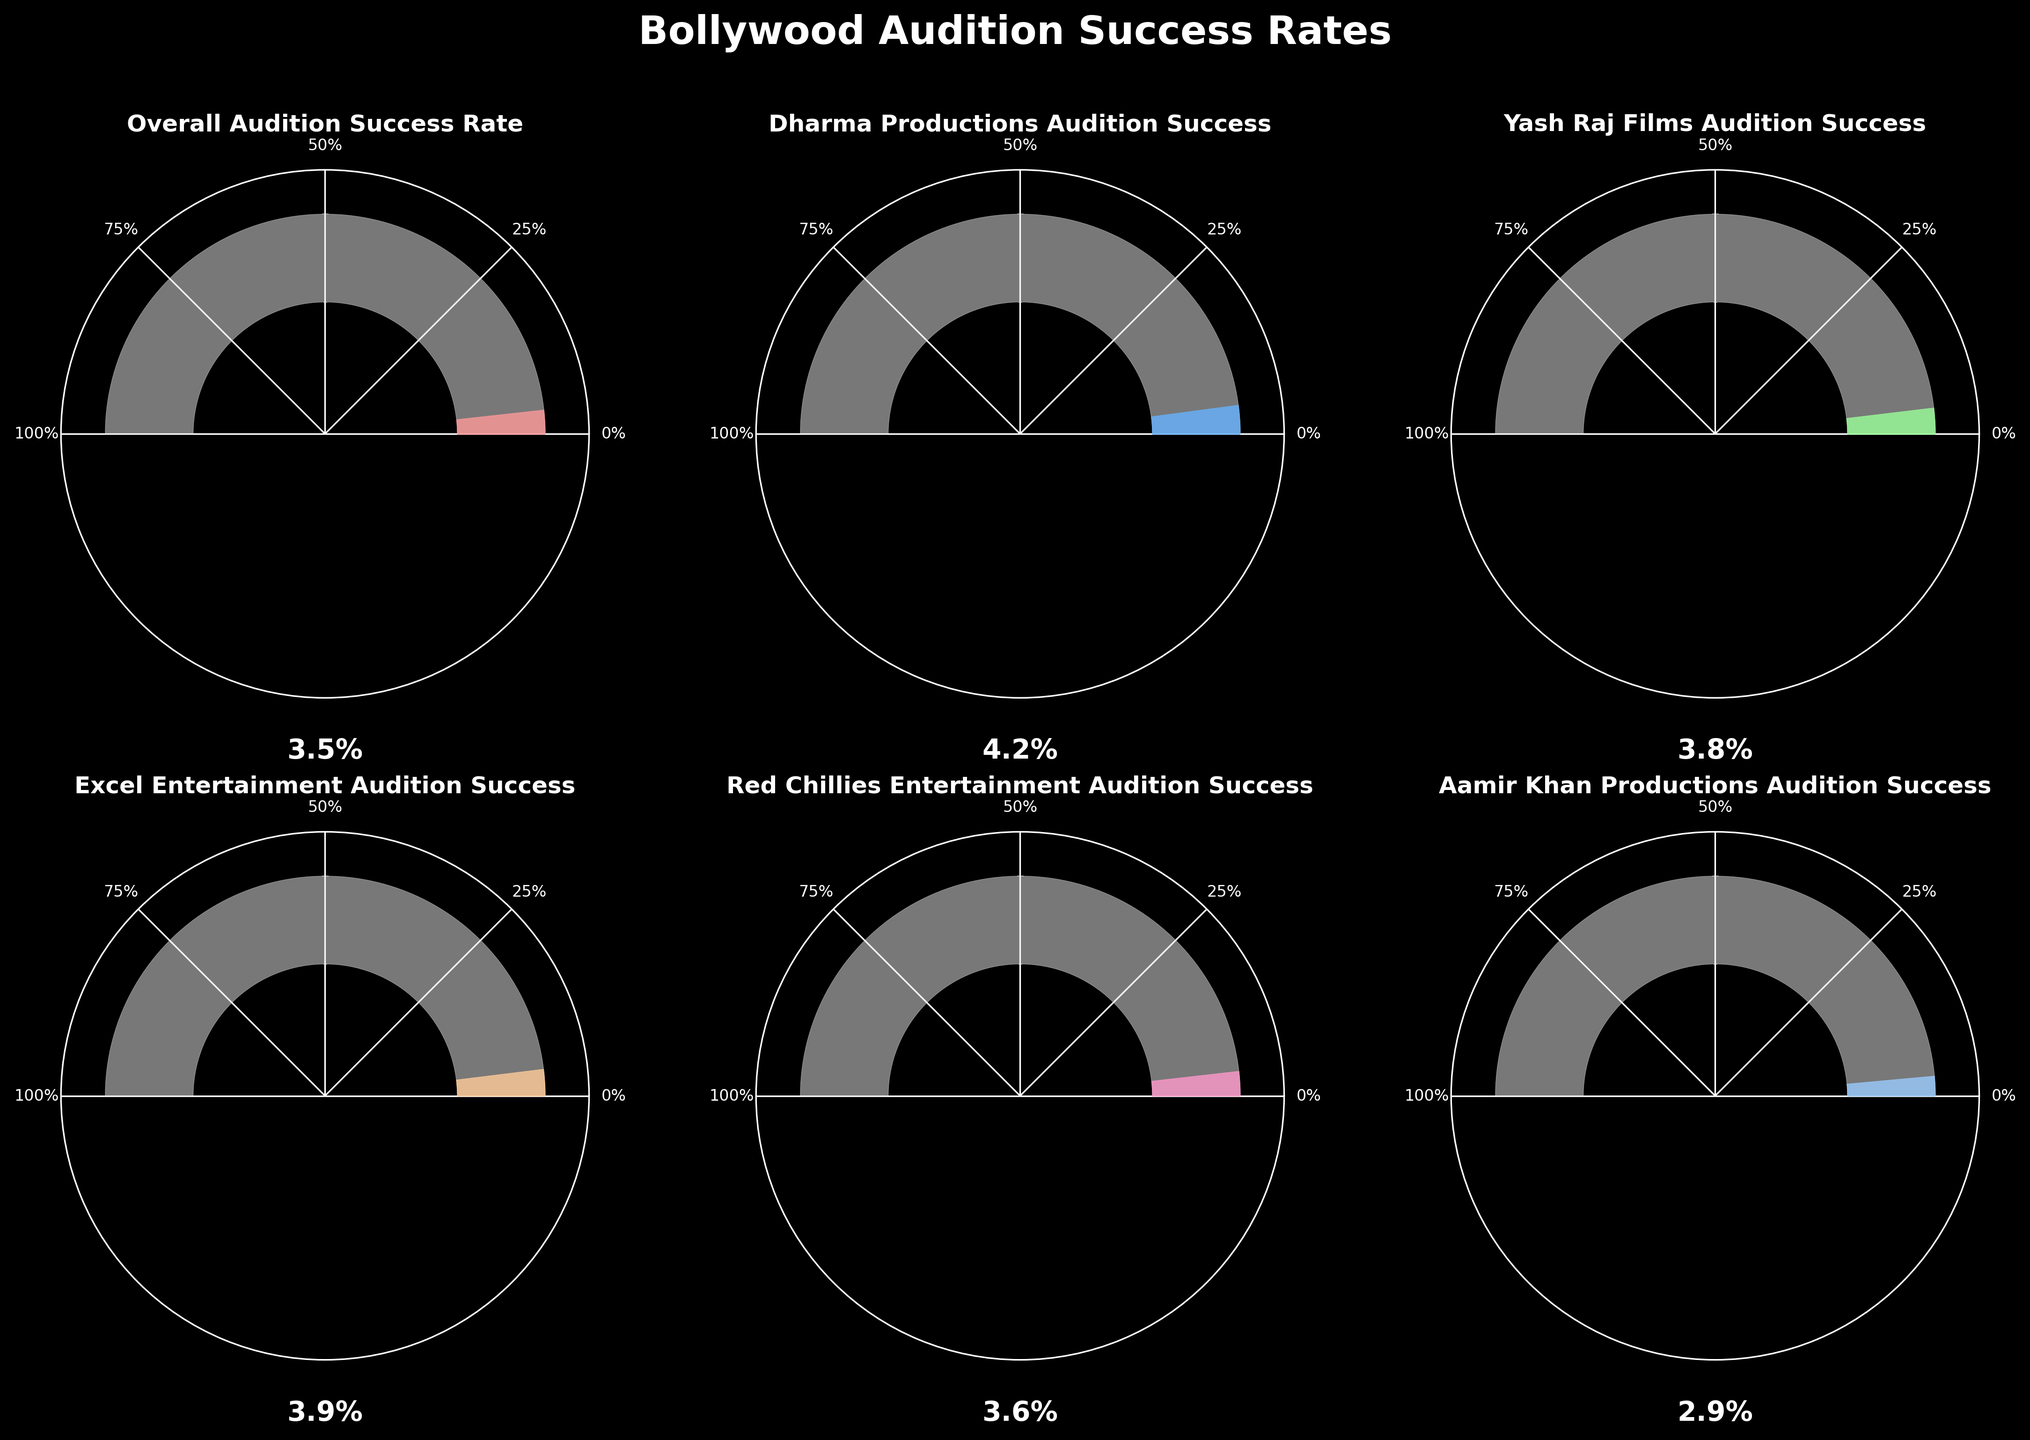What's the overall audition success rate for upcoming Bollywood productions? The title of one of the gauges is "Overall Audition Success Rate," and the value displayed on the gauge is 3.5%. So, the overall audition success rate for upcoming Bollywood productions is 3.5%
Answer: 3.5% Which production house has the highest audition success rate? Among the production houses listed, "Dharma Productions Audition Success" shows the highest value at 4.2% on its gauge.
Answer: Dharma Productions What's the difference in audition success rates between Dharma Productions and Aamir Khan Productions? Dharma Productions has a success rate of 4.2% and Aamir Khan Productions has a success rate of 2.9%. The difference is 4.2% - 2.9% = 1.3%.
Answer: 1.3% How many production houses have a success rate higher than 3.5%? From the gauges: Dharma Productions (4.2%), Yash Raj Films (3.8%), Excel Entertainment (3.9%), and Red Chillies Entertainment (3.6%) all have success rates higher than 3.5%. This totals to 4 production houses.
Answer: 4 What is the average audition success rate for Dharma Productions and Yash Raj Films? Dharma Productions has a 4.2% success rate and Yash Raj Films has a 3.8% success rate. The average is (4.2 + 3.8) / 2 = 4%.
Answer: 4% Is there any production house with an audition success rate close to the overall success rate? The overall audition success rate is 3.5%. Red Chillies Entertainment has an audition success rate of 3.6%, which is closest to the overall rate.
Answer: Red Chillies Entertainment Which production house shows the second highest audition success rate? The highest rate is 4.2% for Dharma Productions. The second highest is 3.9% for Excel Entertainment.
Answer: Excel Entertainment What percentage of production houses have audition success rates below 4%? Five production houses are listed: Except for Dharma Productions (4.2%), the others are below 4%. That's 5 out of 6, which is approximately 83.3%.
Answer: 83.3% What is the total audition success rate if you sum all individual rates provided in the plot? Adding all the given rates: 3.5 + 4.2 + 3.8 + 3.9 + 3.6 + 2.9 = 21.9%.
Answer: 21.9% By how much does Excel Entertainment exceed the overall audition success rate? Excel Entertainment has a 3.9% success rate and the overall rate is 3.5%. The difference is 3.9% - 3.5% = 0.4%.
Answer: 0.4% 